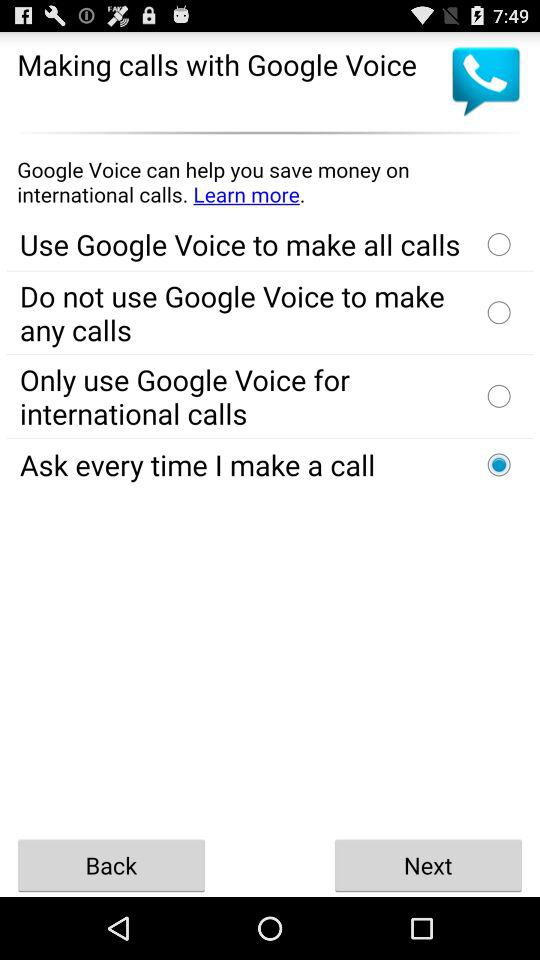How Google voice can save money? How can Google Voice save money? Google Voice can save money on international calls. 